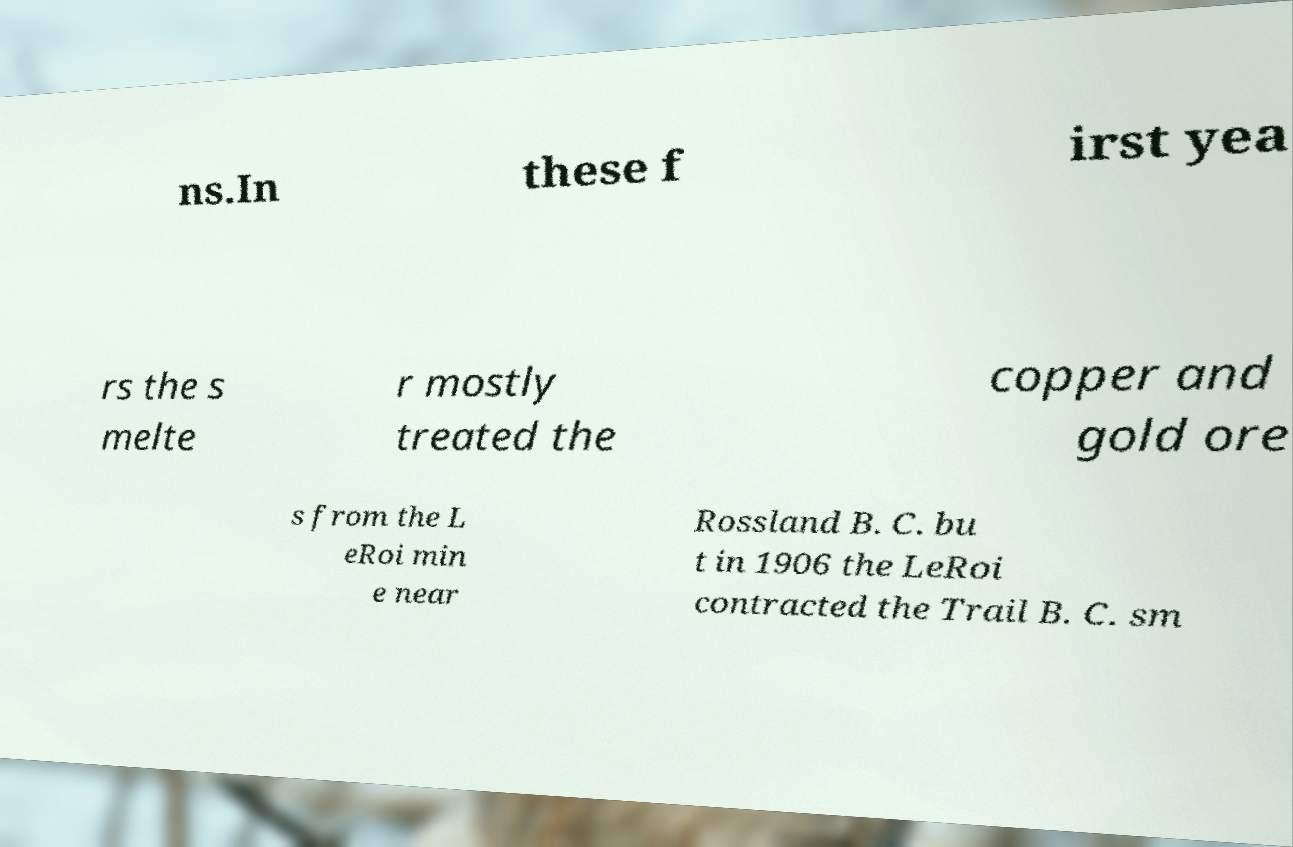Could you assist in decoding the text presented in this image and type it out clearly? ns.In these f irst yea rs the s melte r mostly treated the copper and gold ore s from the L eRoi min e near Rossland B. C. bu t in 1906 the LeRoi contracted the Trail B. C. sm 